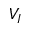Convert formula to latex. <formula><loc_0><loc_0><loc_500><loc_500>V _ { I }</formula> 